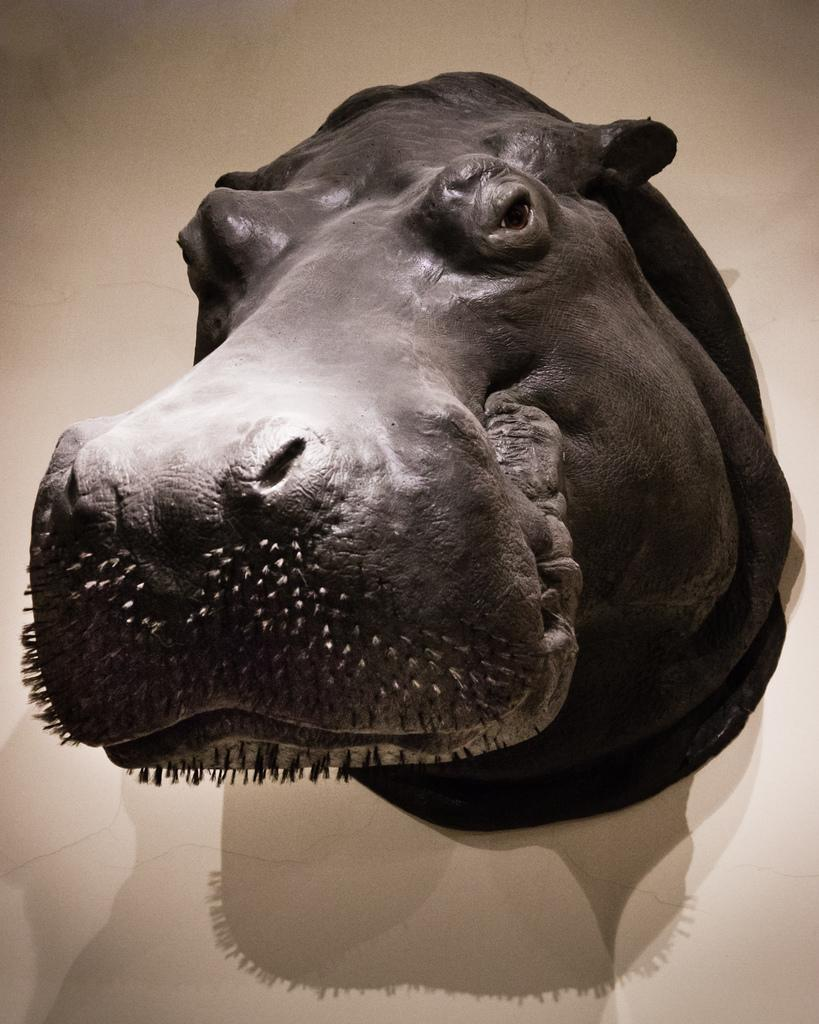What is the main subject of the image? The main subject of the image is a sculpture of an animal. How is the sculpture positioned in the image? The sculpture is attached to the wall. What type of popcorn is being served to the team in the image? There is no popcorn or team present in the image; it features a sculpture of an animal attached to the wall. What color is the sweater worn by the animal in the image? The image is a sculpture, and sculptures do not have clothing like sweaters. 